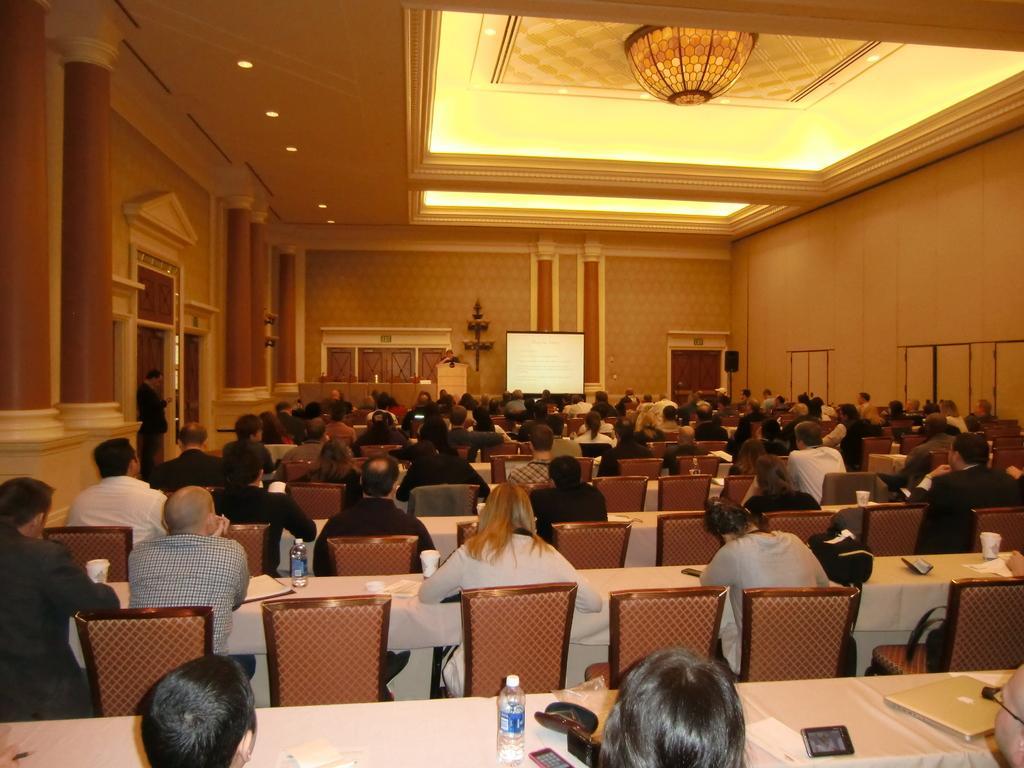How would you summarize this image in a sentence or two? This image consists of many persons sitting on the chairs. And there are many tables covered with white clothes. In the front, we can see a screen and a podium. At the top, there is a roof along with light. On the left, there are pillars. And there are bottles kept on the table. 